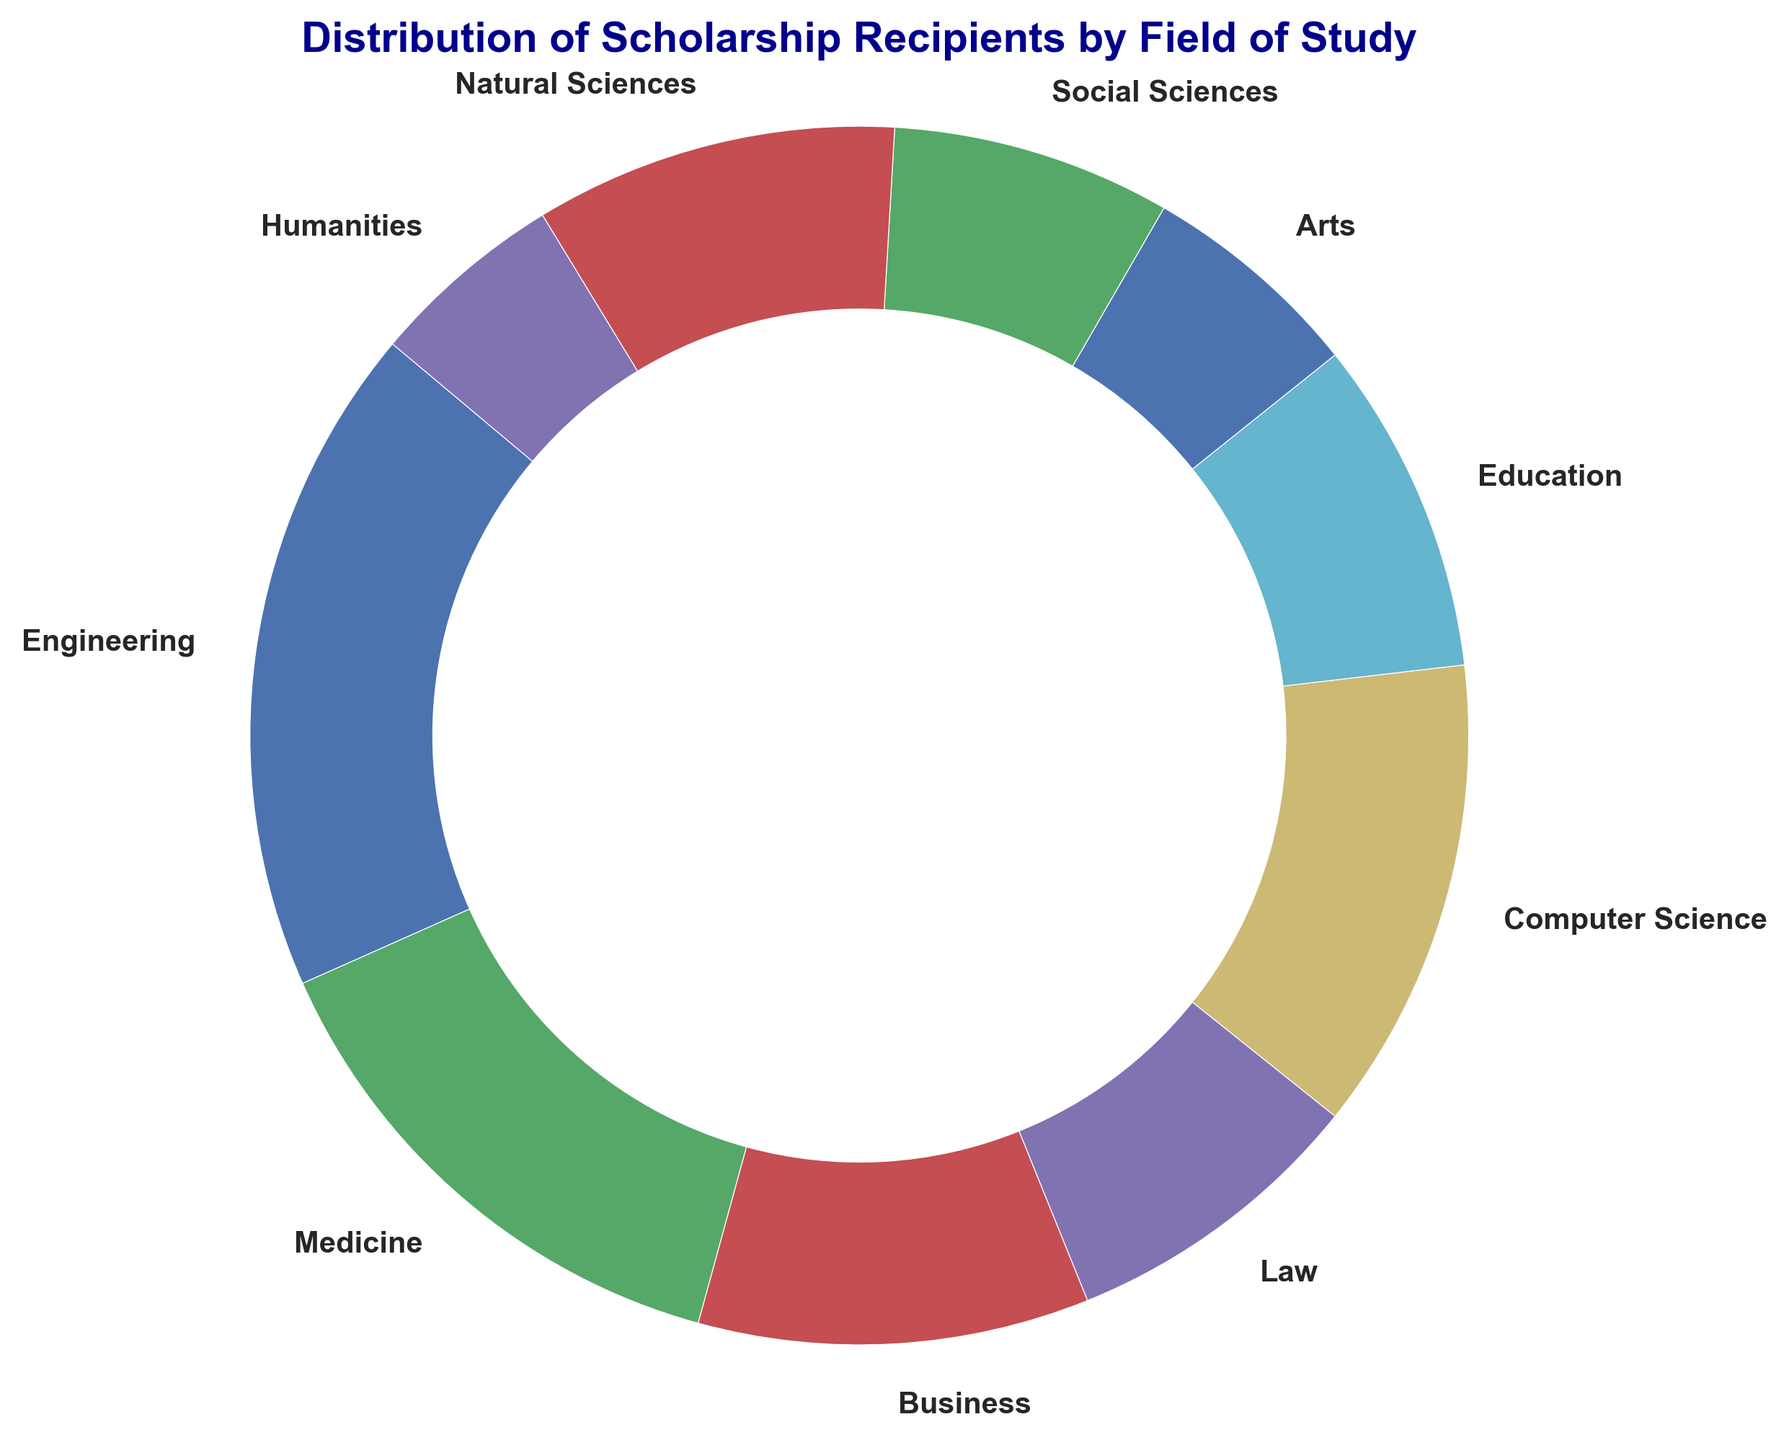What percentage of scholarship recipients are studying Engineering and Medicine combined? First, find the percentage of recipients in Engineering (23.5%) and Medicine (18.6%). Then add these two percentages: 23.5% + 18.6% = 42.1%.
Answer: 42.1% Which field has the highest number of scholarship recipients? Look for the field with the largest share in the ring chart. Engineering has the biggest segment which means it has the highest number of recipients.
Answer: Engineering Are there more scholarship recipients in Education or in Natural Sciences? Compare the segments representing Education and Natural Sciences. The Natural Sciences segment is slightly larger than the Education segment, indicating more recipients in Natural Sciences.
Answer: Natural Sciences What's the combined percentage of scholarship recipients in Social Sciences and Humanities? Find the percentage of Social Sciences (9.8%) and Humanities (6.9%). Then add these two: 9.8% + 6.9% = 16.7%.
Answer: 16.7% How does the number of Computer Science recipients compare to Business? Compare the segments for Computer Science and Business. The Computer Science segment is larger, indicating more recipients in Computer Science than in Business.
Answer: Computer Science What percentage less are the Arts scholarship recipients compared to the Engineering recipients? Engineering recipients are 23.5%, and Arts recipients are 7.8%. Subtract the percentage of Arts from Engineering: 23.5% - 7.8% = 15.7%.
Answer: 15.7% What's the difference in percentage points between the recipients in Medicine and Law? Medicine has 18.6% and Law has 10.8%. The difference is 18.6% - 10.8% = 7.8%.
Answer: 7.8% How many fields have scholarship recipient percentages less than 10%? Identify the segments with less than 10%. These fields are Law (10.8%), Arts (7.8%), Social Sciences (9.8%), Humanities (6.9%). There are four fields exceeding 10%.
Answer: 4 